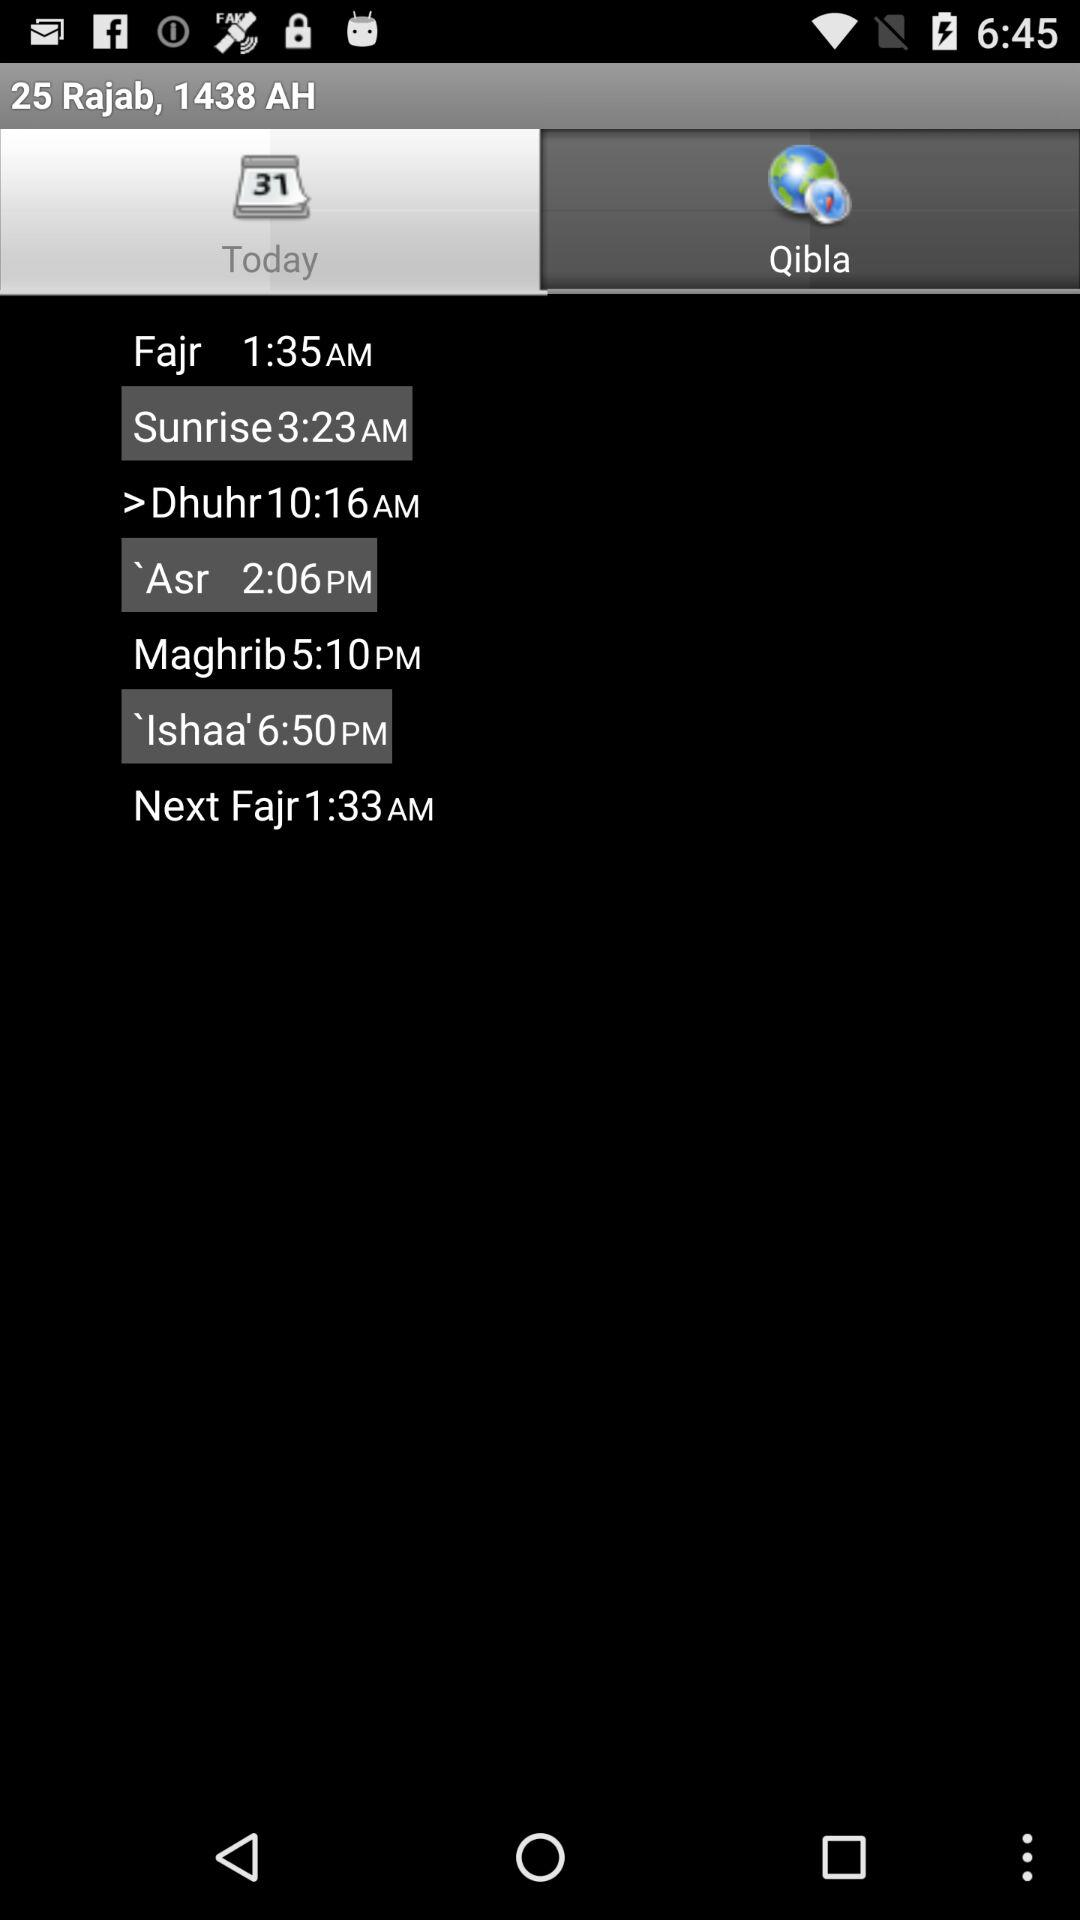What's the sunrise time? The sunrise time is 3:23 a.m. 